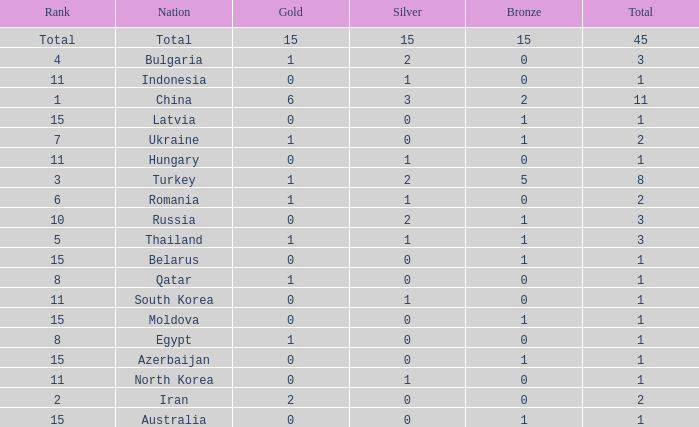What is the sum of the bronze medals of the nation with less than 0 silvers? None. 